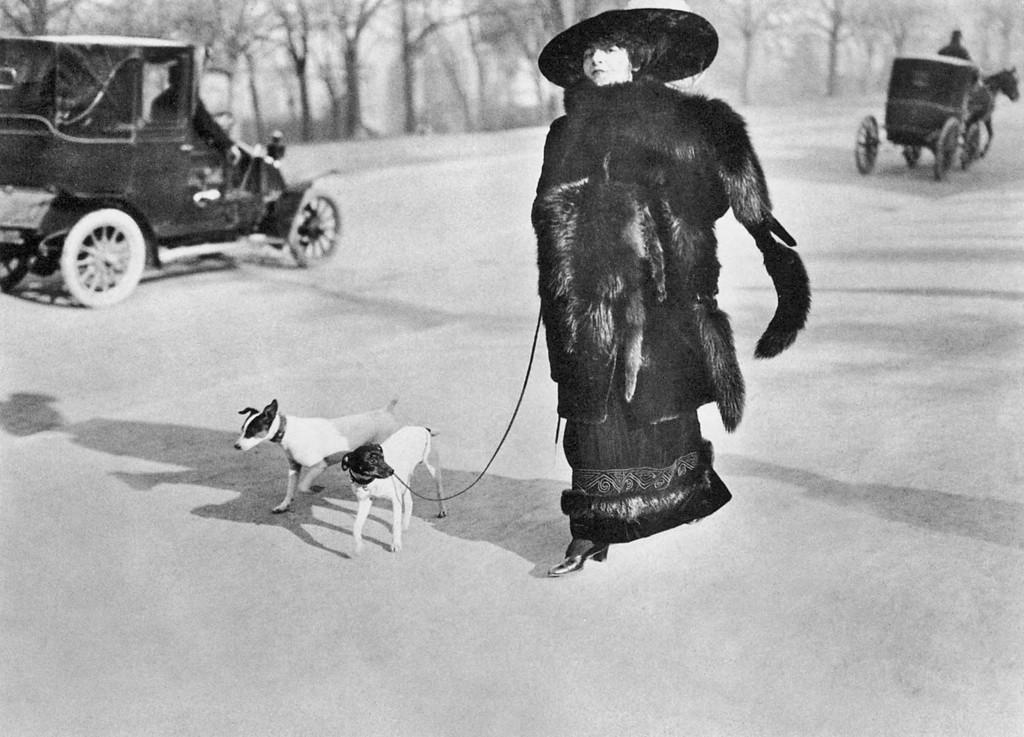What is the person in the image wearing? The person is wearing a black dress in the image. What is the person holding in the image? The person is holding a belt in the image. What is the belt attached to? The belt is tightened to a dog in the image. Are there any other dogs in the image? Yes, there is another dog beside the first dog in the image. What can be seen in the background of the image? There are two vehicles in the background of the image. What type of tree can be seen in the image? There is no tree present in the image. How many beads are on the dog's collar in the image? There are no beads mentioned or visible on the dog's collar in the image. 